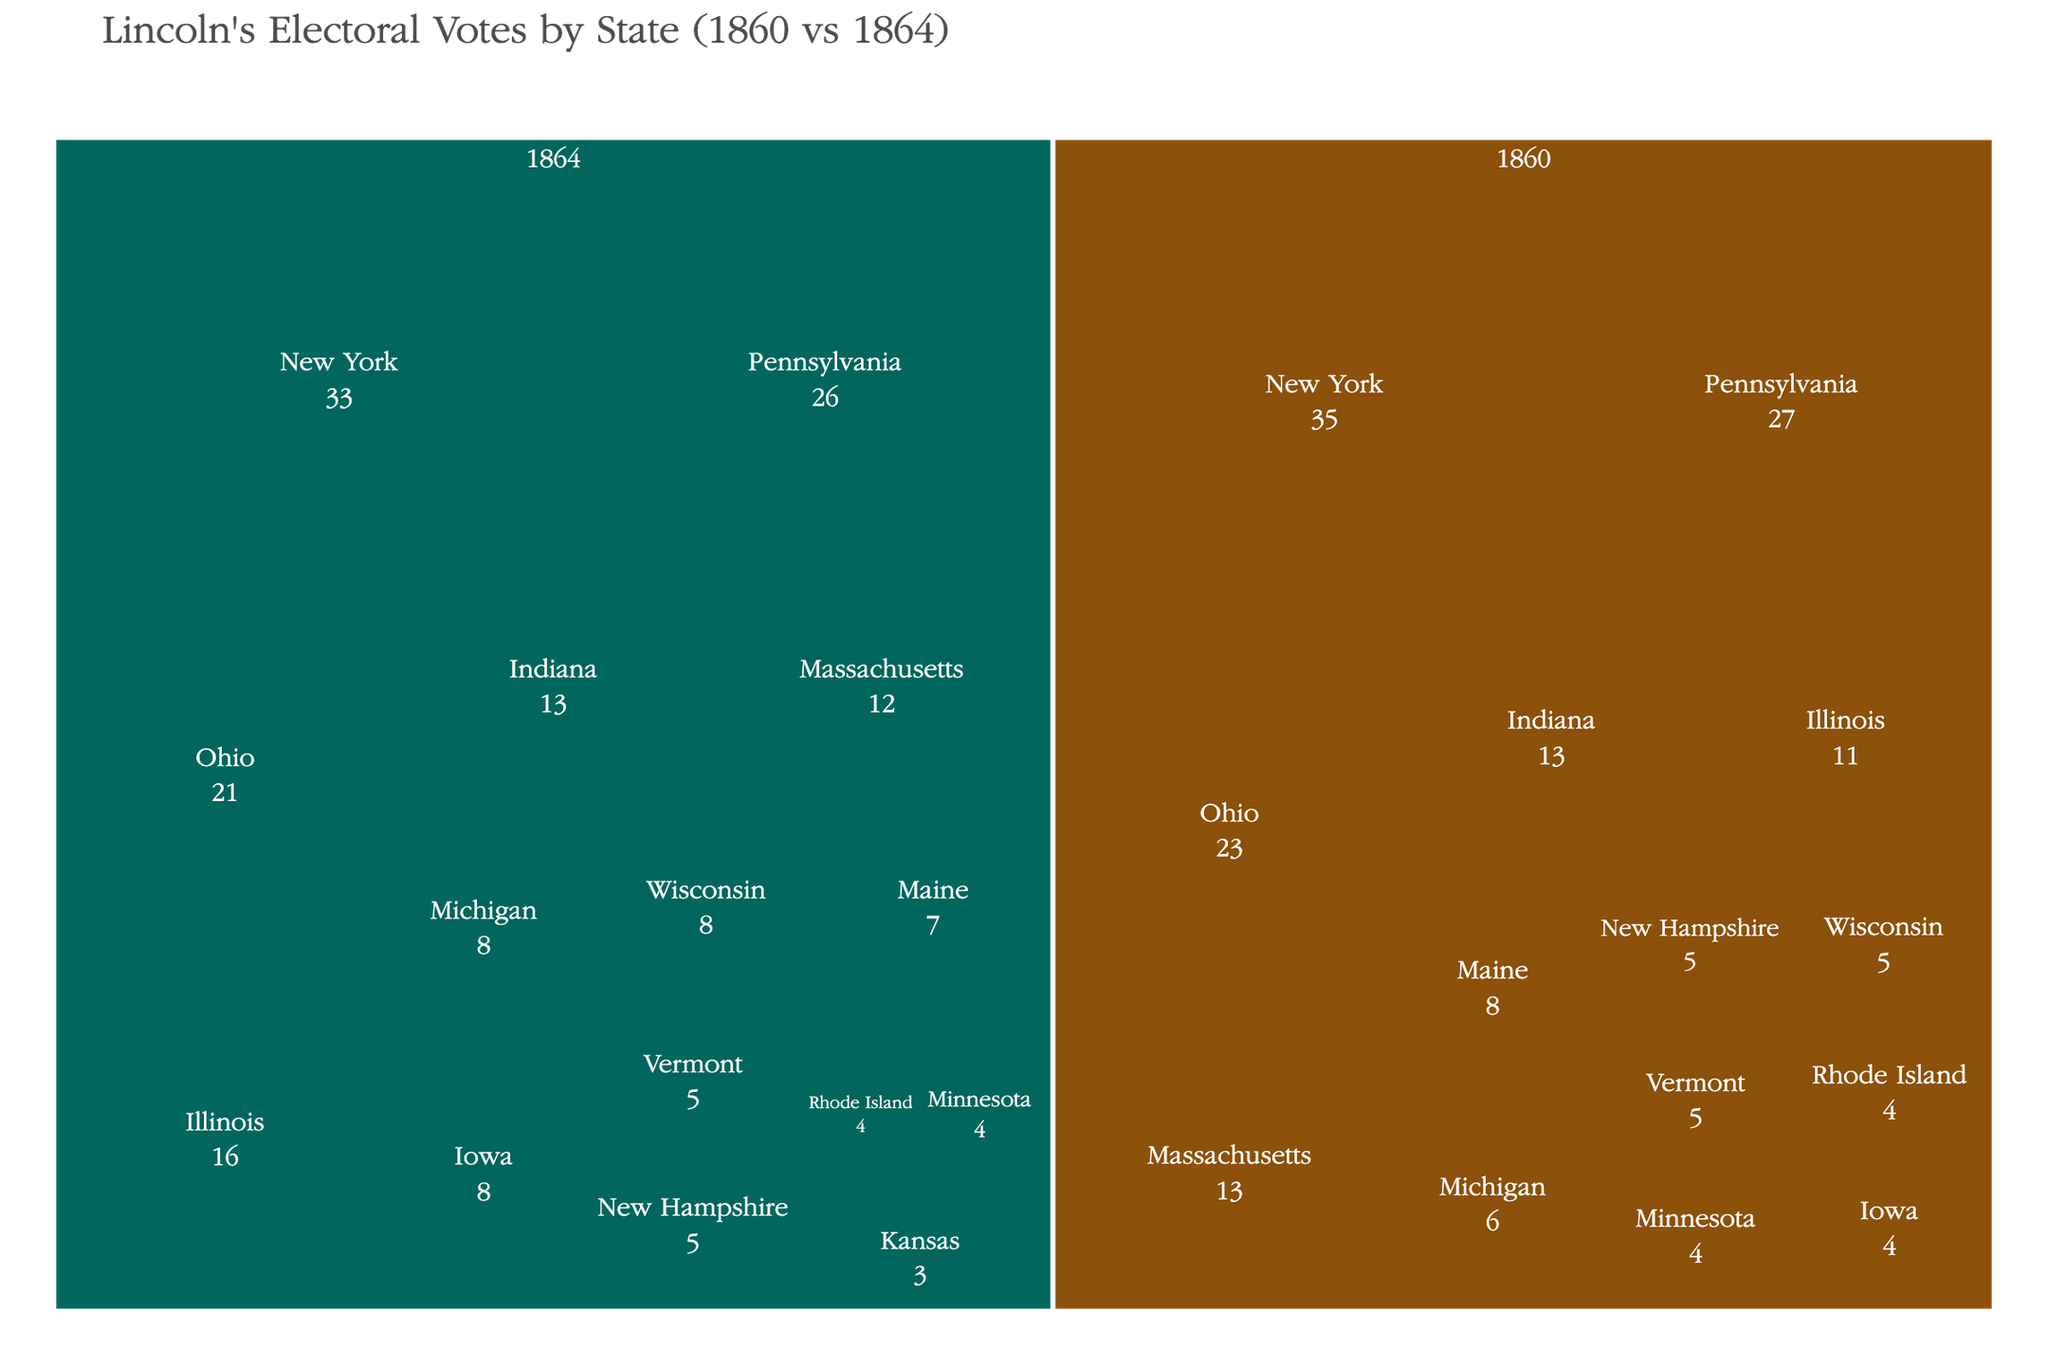What is the title of the Treemap? The title is usually displayed at the top of the figure, summarizing the content of the plot.
Answer: Lincoln's Electoral Votes by State (1860 vs 1864) Which state had the highest electoral votes in 1860? By examining the size of the rectangles and the labels in the 1860 part of the Treemap, we can identify the state with the largest component. In this case, New York has the largest rectangle.
Answer: New York What is the total number of electoral votes Lincoln received in 1864? To get the total, we need to add up the electoral votes of all states for the year 1864. The values are 16 (IL) + 13 (IN) + 8 (IA) + 3 (KS) + 7 (ME) + 12 (MA) + 8 (MI) + 4 (MN) + 5 (NH) + 33 (NY) + 21 (OH) + 26 (PA) + 4 (RI) + 5 (VT) + 8 (WI) = 169.
Answer: 169 Which year had more total electoral votes, 1860 or 1864? We calculate the total electoral votes for both years and compare them. For 1860: 11 (IL) + 13 (IN) + 4 (IA) + 8 (ME) + 13 (MA) + 6 (MI) + 4 (MN) + 5 (NH) + 35 (NY) + 23 (OH) + 27 (PA) + 4 (RI) + 5 (VT) + 5 (WI) = 163. Comparing with the 169 in 1864, 1864 has more votes.
Answer: 1864 How did Illinois' electoral votes change between 1860 and 1864? The Treemap shows that Illinois had 11 electoral votes in 1860 and 16 in 1864. By comparing these values, we observe how the electoral votes increased by (16 - 11) = 5 votes.
Answer: Increased by 5 Which states had the same number of electoral votes in both 1860 and 1864? By examining the Treemap, we can spot states that have identical values for both years. Minnesota, New Hampshire, and Rhode Island each had electoral votes of 4, 5, and 4 respectively in both years.
Answer: Minnesota, New Hampshire, Rhode Island What is the difference in electoral votes between New York and Pennsylvania in 1860? According to the Treemap, New York had 35 electoral votes in 1860 while Pennsylvania had 27. The difference is calculated as (35 - 27) = 8 votes.
Answer: 8 In 1864, which state showed the largest increase in electoral votes compared to 1860? By comparing electoral votes for each state between the two years, we see Iowa increased from 4 to 8 votes — an increase of 4 votes. This is the largest increase among those states.
Answer: Iowa How did the total combined electoral votes of Pennsylvania and Ohio change from 1860 to 1864? Summing the electoral votes for Pennsylvania and Ohio in 1860 is (27 for PA + 23 for OH = 50), and in 1864 is (26 for PA + 21 for OH = 47). The change is (50 - 47) = 3 fewer votes.
Answer: Decreased by 3 